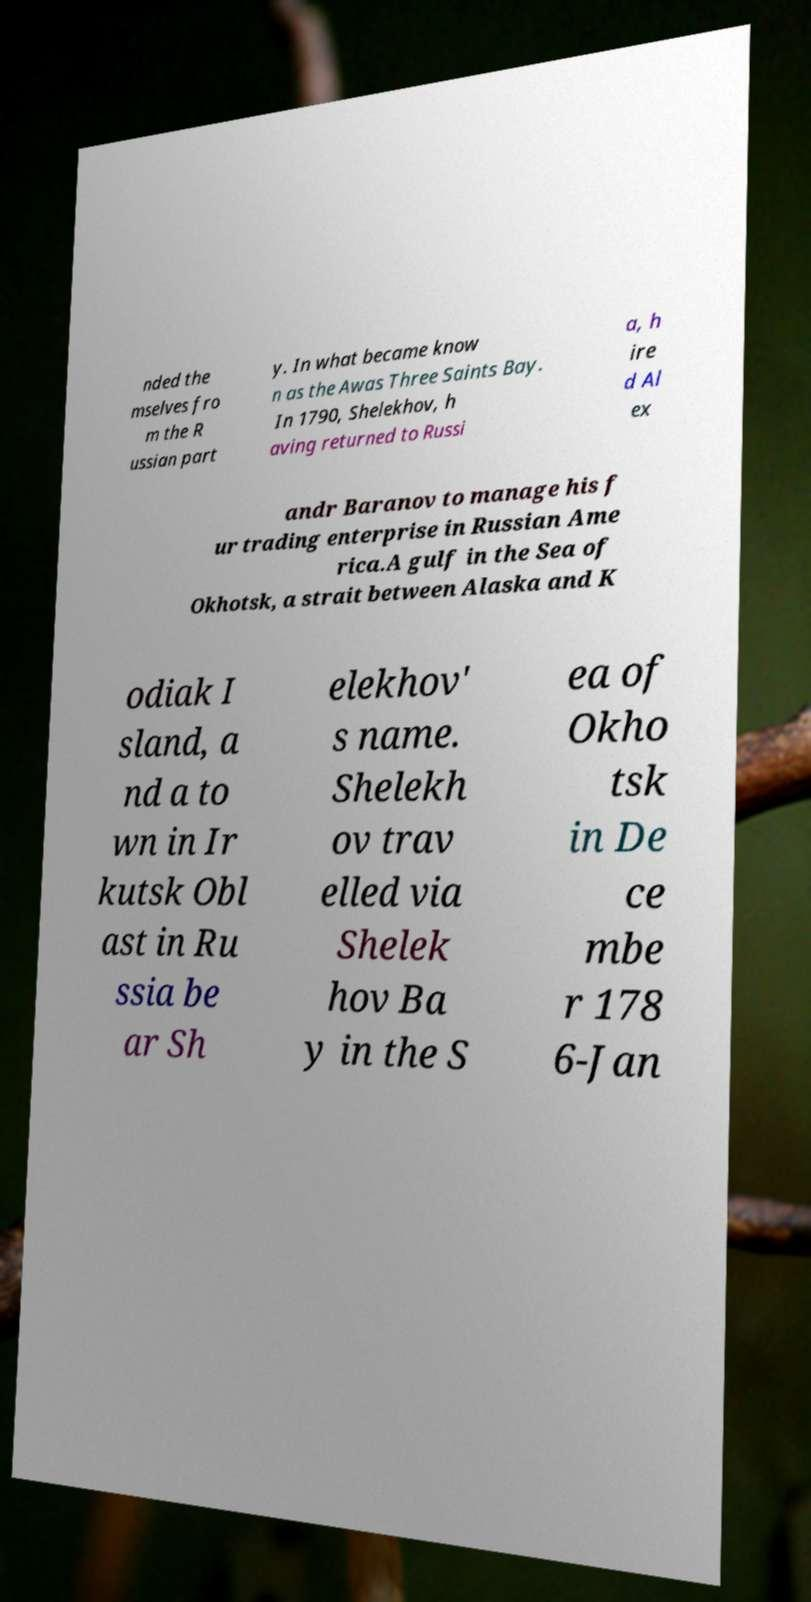What messages or text are displayed in this image? I need them in a readable, typed format. nded the mselves fro m the R ussian part y. In what became know n as the Awas Three Saints Bay. In 1790, Shelekhov, h aving returned to Russi a, h ire d Al ex andr Baranov to manage his f ur trading enterprise in Russian Ame rica.A gulf in the Sea of Okhotsk, a strait between Alaska and K odiak I sland, a nd a to wn in Ir kutsk Obl ast in Ru ssia be ar Sh elekhov' s name. Shelekh ov trav elled via Shelek hov Ba y in the S ea of Okho tsk in De ce mbe r 178 6-Jan 